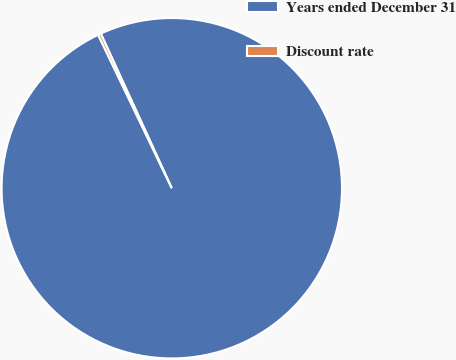Convert chart. <chart><loc_0><loc_0><loc_500><loc_500><pie_chart><fcel>Years ended December 31<fcel>Discount rate<nl><fcel>99.73%<fcel>0.27%<nl></chart> 